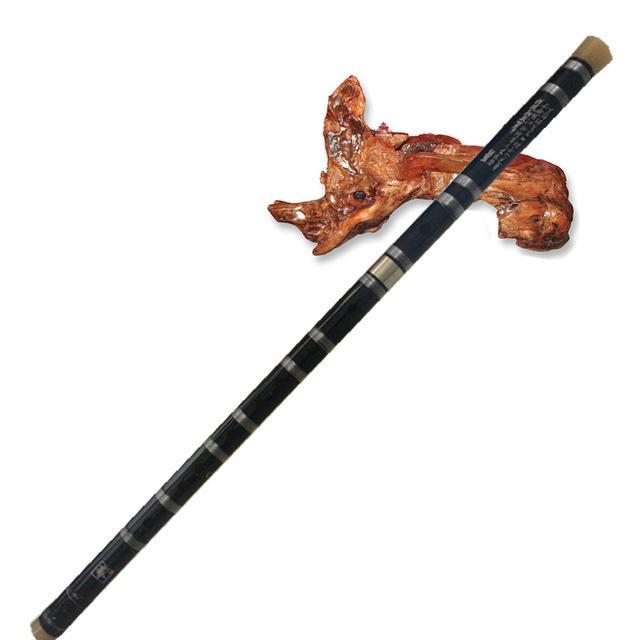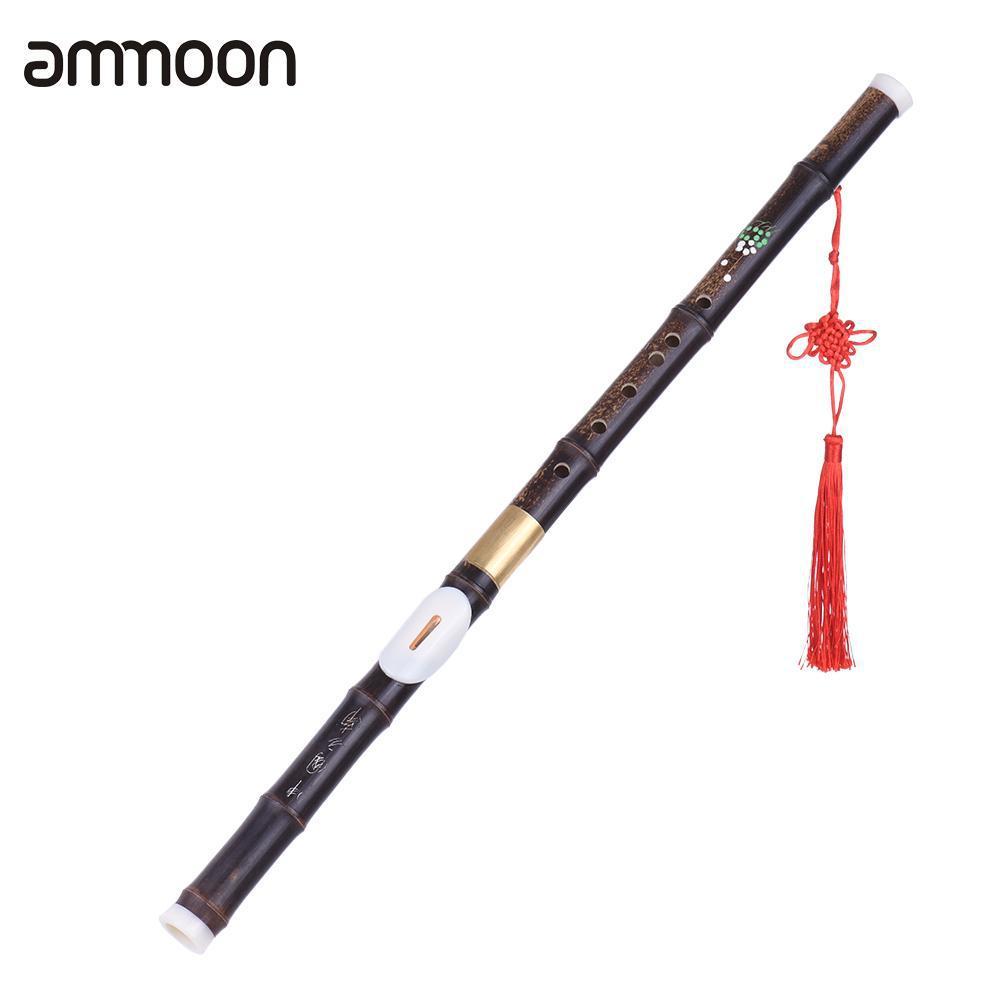The first image is the image on the left, the second image is the image on the right. Examine the images to the left and right. Is the description "There are exactly two flutes." accurate? Answer yes or no. Yes. The first image is the image on the left, the second image is the image on the right. Considering the images on both sides, is "There is a total of two instruments." valid? Answer yes or no. Yes. 